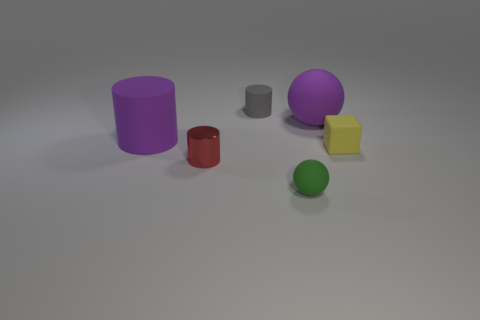Subtract all rubber cylinders. How many cylinders are left? 1 Subtract all purple cylinders. How many cylinders are left? 2 Add 1 large green metal cylinders. How many objects exist? 7 Subtract all blocks. How many objects are left? 5 Subtract 1 cylinders. How many cylinders are left? 2 Add 3 purple matte objects. How many purple matte objects are left? 5 Add 3 big purple matte things. How many big purple matte things exist? 5 Subtract 0 yellow cylinders. How many objects are left? 6 Subtract all blue cylinders. Subtract all purple blocks. How many cylinders are left? 3 Subtract all gray blocks. How many purple balls are left? 1 